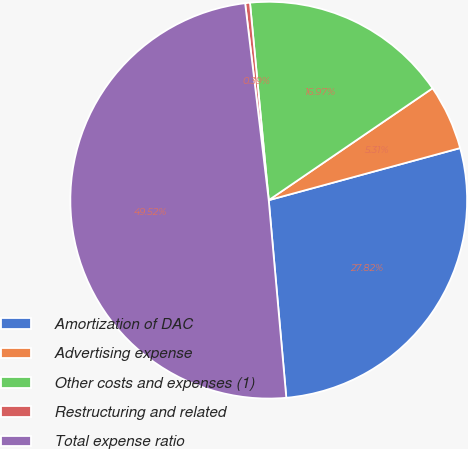Convert chart. <chart><loc_0><loc_0><loc_500><loc_500><pie_chart><fcel>Amortization of DAC<fcel>Advertising expense<fcel>Other costs and expenses (1)<fcel>Restructuring and related<fcel>Total expense ratio<nl><fcel>27.82%<fcel>5.31%<fcel>16.97%<fcel>0.39%<fcel>49.52%<nl></chart> 